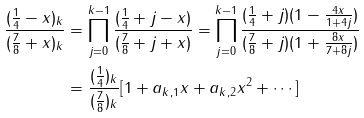Convert formula to latex. <formula><loc_0><loc_0><loc_500><loc_500>\frac { ( \frac { 1 } { 4 } - x ) _ { k } } { ( \frac { 7 } { 8 } + x ) _ { k } } & = \prod _ { j = 0 } ^ { k - 1 } \frac { ( \frac { 1 } { 4 } + j - x ) } { ( \frac { 7 } { 8 } + j + x ) } = \prod _ { j = 0 } ^ { k - 1 } \frac { ( \frac { 1 } { 4 } + j ) ( 1 - \frac { 4 x } { 1 + 4 j } ) } { ( \frac { 7 } { 8 } + j ) ( 1 + \frac { 8 x } { 7 + 8 j } ) } \\ & = \frac { ( \frac { 1 } { 4 } ) _ { k } } { ( \frac { 7 } { 8 } ) _ { k } } [ 1 + a _ { k , 1 } x + a _ { k , 2 } x ^ { 2 } + \cdots ]</formula> 